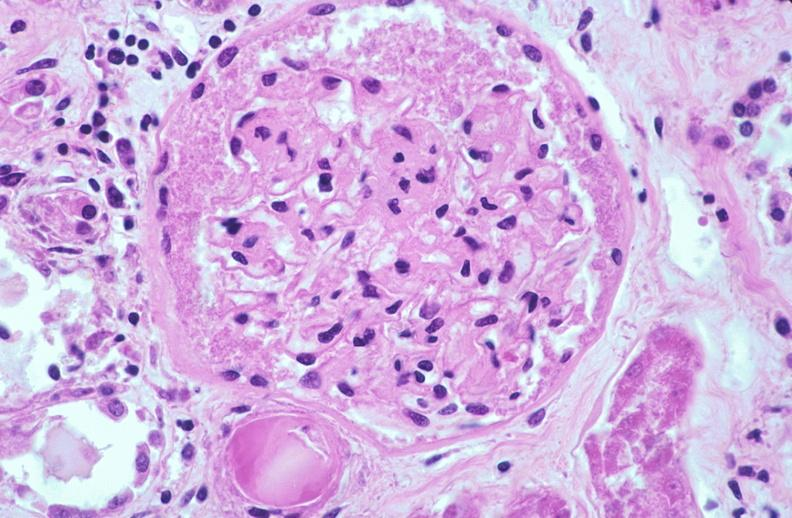why does this image show kidney glomerulus, thickened and hyalinized basement membranes fibrin caps?
Answer the question using a single word or phrase. Due to diabetes mellitus 